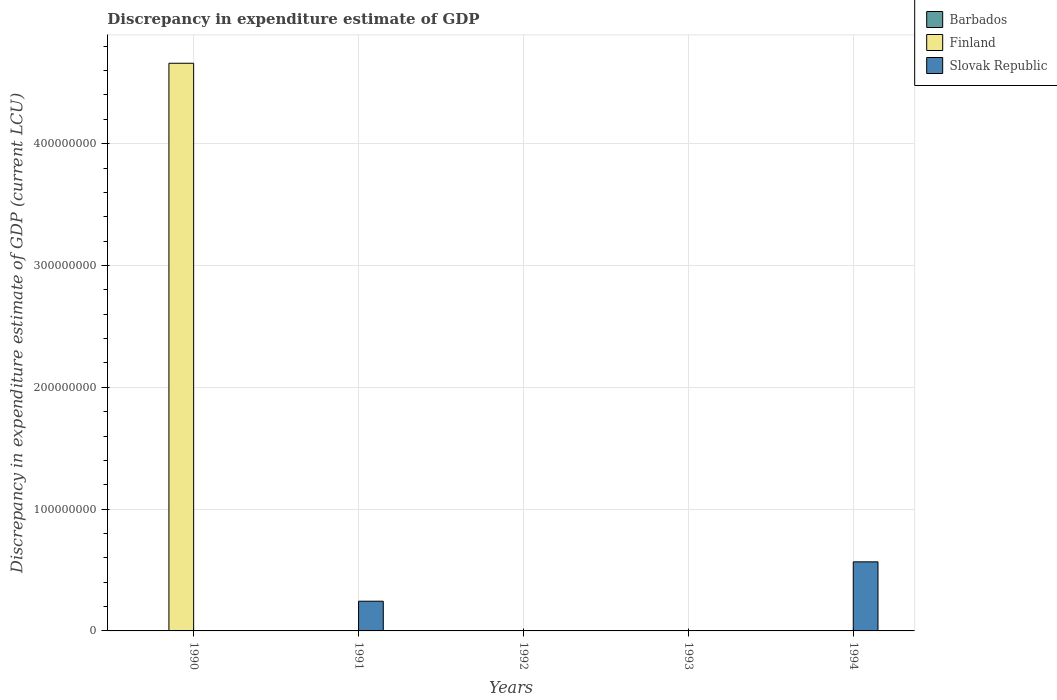How many different coloured bars are there?
Your answer should be very brief. 2. Are the number of bars per tick equal to the number of legend labels?
Keep it short and to the point. No. What is the label of the 5th group of bars from the left?
Make the answer very short. 1994. What is the discrepancy in expenditure estimate of GDP in Finland in 1990?
Your answer should be compact. 4.66e+08. Across all years, what is the maximum discrepancy in expenditure estimate of GDP in Slovak Republic?
Provide a short and direct response. 5.67e+07. What is the total discrepancy in expenditure estimate of GDP in Slovak Republic in the graph?
Keep it short and to the point. 8.11e+07. What is the difference between the highest and the lowest discrepancy in expenditure estimate of GDP in Slovak Republic?
Offer a very short reply. 5.67e+07. Is it the case that in every year, the sum of the discrepancy in expenditure estimate of GDP in Barbados and discrepancy in expenditure estimate of GDP in Slovak Republic is greater than the discrepancy in expenditure estimate of GDP in Finland?
Ensure brevity in your answer.  No. How many bars are there?
Make the answer very short. 3. Are the values on the major ticks of Y-axis written in scientific E-notation?
Make the answer very short. No. Does the graph contain any zero values?
Make the answer very short. Yes. Does the graph contain grids?
Offer a terse response. Yes. How many legend labels are there?
Provide a succinct answer. 3. What is the title of the graph?
Your response must be concise. Discrepancy in expenditure estimate of GDP. Does "Fiji" appear as one of the legend labels in the graph?
Keep it short and to the point. No. What is the label or title of the X-axis?
Offer a very short reply. Years. What is the label or title of the Y-axis?
Give a very brief answer. Discrepancy in expenditure estimate of GDP (current LCU). What is the Discrepancy in expenditure estimate of GDP (current LCU) in Barbados in 1990?
Provide a succinct answer. 0. What is the Discrepancy in expenditure estimate of GDP (current LCU) of Finland in 1990?
Make the answer very short. 4.66e+08. What is the Discrepancy in expenditure estimate of GDP (current LCU) of Slovak Republic in 1990?
Offer a very short reply. 0. What is the Discrepancy in expenditure estimate of GDP (current LCU) of Finland in 1991?
Keep it short and to the point. 0. What is the Discrepancy in expenditure estimate of GDP (current LCU) of Slovak Republic in 1991?
Provide a short and direct response. 2.44e+07. What is the Discrepancy in expenditure estimate of GDP (current LCU) in Slovak Republic in 1992?
Ensure brevity in your answer.  0. What is the Discrepancy in expenditure estimate of GDP (current LCU) of Barbados in 1993?
Your response must be concise. 0. What is the Discrepancy in expenditure estimate of GDP (current LCU) of Slovak Republic in 1993?
Offer a very short reply. 0. What is the Discrepancy in expenditure estimate of GDP (current LCU) in Barbados in 1994?
Ensure brevity in your answer.  0. What is the Discrepancy in expenditure estimate of GDP (current LCU) of Slovak Republic in 1994?
Offer a terse response. 5.67e+07. Across all years, what is the maximum Discrepancy in expenditure estimate of GDP (current LCU) in Finland?
Ensure brevity in your answer.  4.66e+08. Across all years, what is the maximum Discrepancy in expenditure estimate of GDP (current LCU) in Slovak Republic?
Your response must be concise. 5.67e+07. What is the total Discrepancy in expenditure estimate of GDP (current LCU) of Barbados in the graph?
Provide a succinct answer. 0. What is the total Discrepancy in expenditure estimate of GDP (current LCU) in Finland in the graph?
Provide a succinct answer. 4.66e+08. What is the total Discrepancy in expenditure estimate of GDP (current LCU) in Slovak Republic in the graph?
Your answer should be compact. 8.11e+07. What is the difference between the Discrepancy in expenditure estimate of GDP (current LCU) of Slovak Republic in 1991 and that in 1994?
Make the answer very short. -3.23e+07. What is the difference between the Discrepancy in expenditure estimate of GDP (current LCU) in Finland in 1990 and the Discrepancy in expenditure estimate of GDP (current LCU) in Slovak Republic in 1991?
Give a very brief answer. 4.42e+08. What is the difference between the Discrepancy in expenditure estimate of GDP (current LCU) in Finland in 1990 and the Discrepancy in expenditure estimate of GDP (current LCU) in Slovak Republic in 1994?
Keep it short and to the point. 4.09e+08. What is the average Discrepancy in expenditure estimate of GDP (current LCU) of Barbados per year?
Provide a succinct answer. 0. What is the average Discrepancy in expenditure estimate of GDP (current LCU) in Finland per year?
Offer a very short reply. 9.32e+07. What is the average Discrepancy in expenditure estimate of GDP (current LCU) in Slovak Republic per year?
Your response must be concise. 1.62e+07. What is the ratio of the Discrepancy in expenditure estimate of GDP (current LCU) in Slovak Republic in 1991 to that in 1994?
Offer a terse response. 0.43. What is the difference between the highest and the lowest Discrepancy in expenditure estimate of GDP (current LCU) of Finland?
Your response must be concise. 4.66e+08. What is the difference between the highest and the lowest Discrepancy in expenditure estimate of GDP (current LCU) of Slovak Republic?
Give a very brief answer. 5.67e+07. 